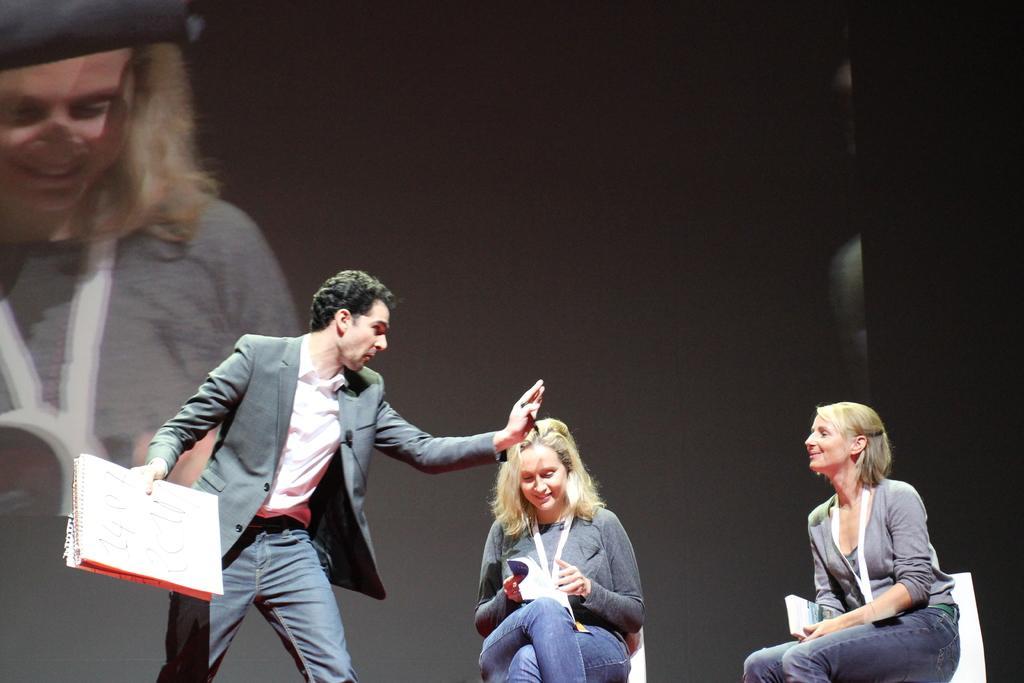How would you summarize this image in a sentence or two? On the left side, there is a person in a suit, holding a pen with a hand and holding a book with the other hand. On the right side, there are two women in the gray color T-shirts, sitting on the white color chairs. In the background, there is a screen. And the background is dark in color. 